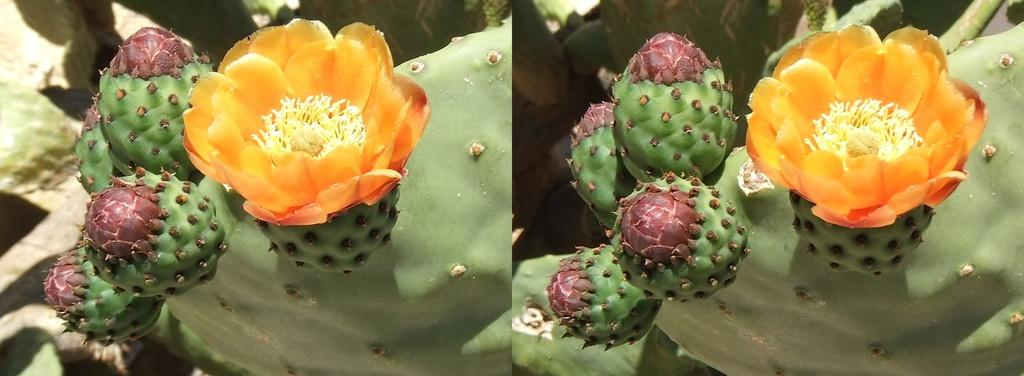What type of image is being described? The image is a parallax image. What is the main subject of the image? The subject of the image is an eastern prickly pear cactus. How many feet are visible in the image? There are no feet visible in the image, as it features an eastern prickly pear cactus. 